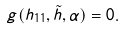<formula> <loc_0><loc_0><loc_500><loc_500>g ( h _ { 1 1 } , \tilde { h } , \alpha ) = 0 .</formula> 